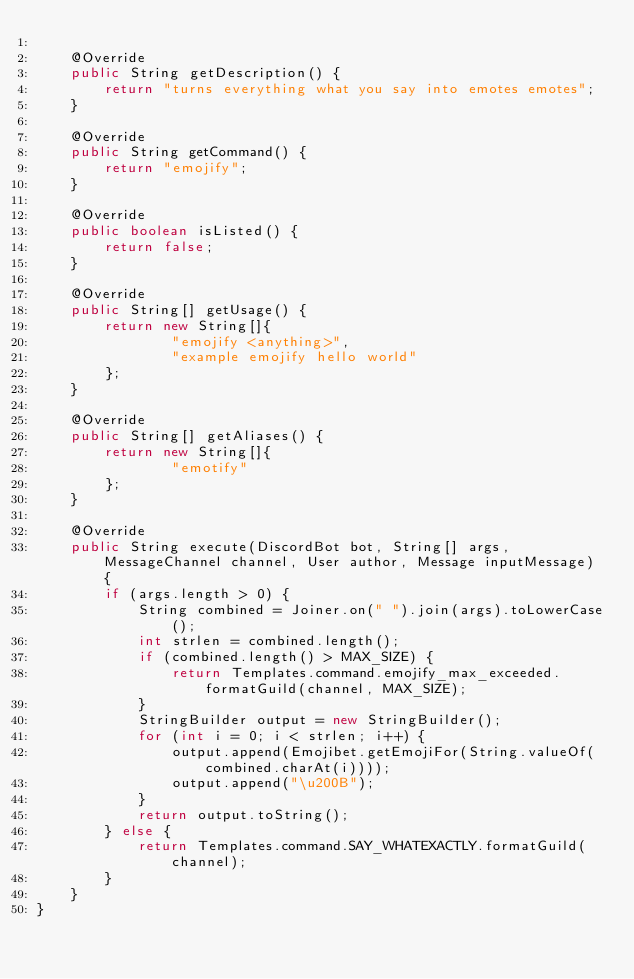Convert code to text. <code><loc_0><loc_0><loc_500><loc_500><_Java_>
    @Override
    public String getDescription() {
        return "turns everything what you say into emotes emotes";
    }

    @Override
    public String getCommand() {
        return "emojify";
    }

    @Override
    public boolean isListed() {
        return false;
    }

    @Override
    public String[] getUsage() {
        return new String[]{
                "emojify <anything>",
                "example emojify hello world"
        };
    }

    @Override
    public String[] getAliases() {
        return new String[]{
                "emotify"
        };
    }

    @Override
    public String execute(DiscordBot bot, String[] args, MessageChannel channel, User author, Message inputMessage) {
        if (args.length > 0) {
            String combined = Joiner.on(" ").join(args).toLowerCase();
            int strlen = combined.length();
            if (combined.length() > MAX_SIZE) {
                return Templates.command.emojify_max_exceeded.formatGuild(channel, MAX_SIZE);
            }
            StringBuilder output = new StringBuilder();
            for (int i = 0; i < strlen; i++) {
                output.append(Emojibet.getEmojiFor(String.valueOf(combined.charAt(i))));
                output.append("\u200B");
            }
            return output.toString();
        } else {
            return Templates.command.SAY_WHATEXACTLY.formatGuild(channel);
        }
    }
}</code> 